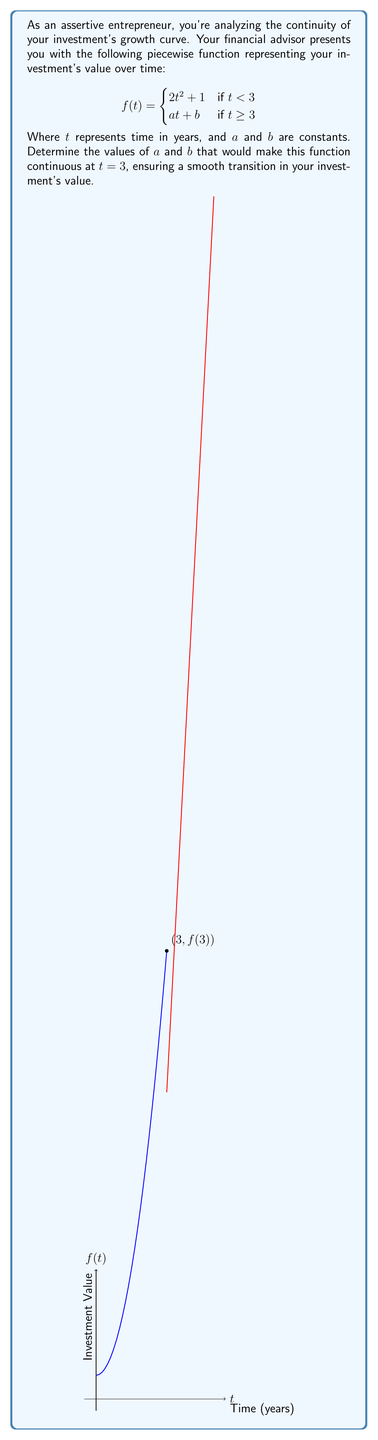Provide a solution to this math problem. Let's approach this step-by-step:

1) For a function to be continuous at a point, it must satisfy three conditions:
   a) The function must be defined at that point
   b) The limit of the function as we approach the point from both sides must exist
   c) The limit must equal the function's value at that point

2) We need to make $f(t)$ continuous at $t = 3$. Let's start by finding $f(3)$ using the first piece of the function:

   $f(3) = 2(3)^2 + 1 = 2(9) + 1 = 18 + 1 = 19$

3) For continuity, we need the second piece of the function to equal 19 when $t = 3$:

   $a(3) + b = 19$ ... (Equation 1)

4) We also need the derivatives of both pieces to be equal at $t = 3$ for smoothness:

   Left derivative: $\frac{d}{dt}(2t^2 + 1) = 4t$
   At $t = 3$: $4(3) = 12$

   Right derivative: $\frac{d}{dt}(at + b) = a$

   For smoothness: $a = 12$ ... (Equation 2)

5) Substituting $a = 12$ into Equation 1:

   $12(3) + b = 19$
   $36 + b = 19$
   $b = 19 - 36 = -17$

Therefore, $a = 12$ and $b = -17$.

6) Let's verify:
   Left limit: $\lim_{t \to 3^-} (2t^2 + 1) = 2(3)^2 + 1 = 19$
   Right limit: $\lim_{t \to 3^+} (12t - 17) = 12(3) - 17 = 19$

   Both limits equal $f(3)$, confirming continuity.
Answer: $a = 12$, $b = -17$ 